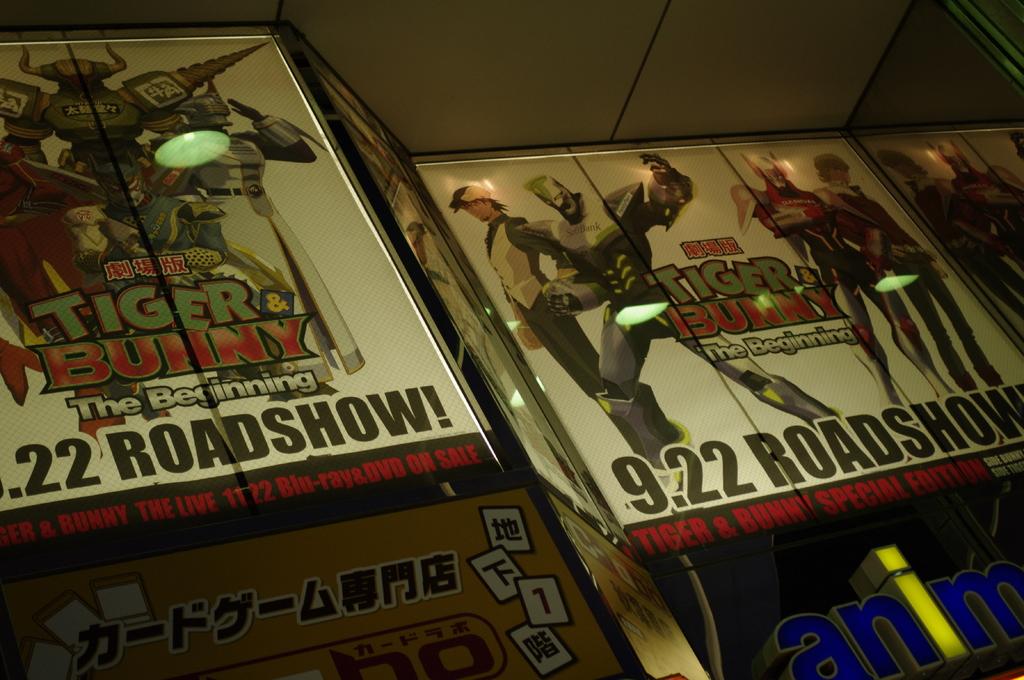What are the names of the two characters pictured here?
Offer a terse response. Tiger and bunny. What show is advertised on this photo?
Make the answer very short. 9.22 roadshow. 